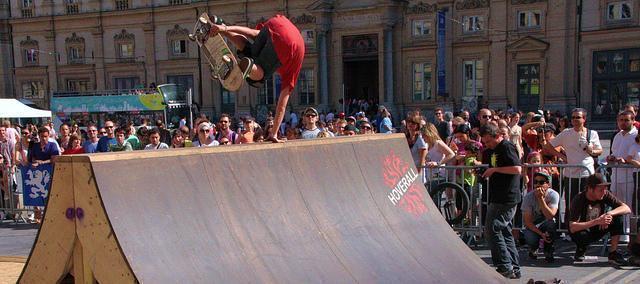What maneuver is the man wearing red performing?
Answer the question by selecting the correct answer among the 4 following choices.
Options: Grind, front spin, hand plant, big air. Hand plant. 